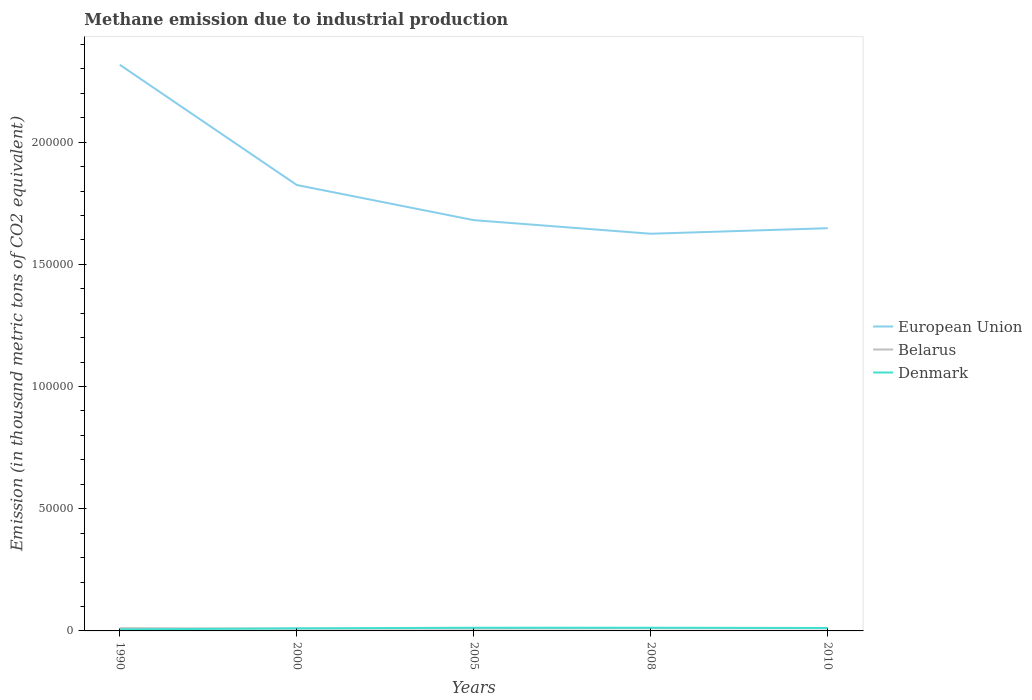Across all years, what is the maximum amount of methane emitted in Belarus?
Provide a succinct answer. 934.2. What is the total amount of methane emitted in Belarus in the graph?
Offer a terse response. -121.9. What is the difference between the highest and the second highest amount of methane emitted in European Union?
Offer a terse response. 6.91e+04. Is the amount of methane emitted in European Union strictly greater than the amount of methane emitted in Denmark over the years?
Provide a succinct answer. No. Does the graph contain any zero values?
Provide a short and direct response. No. Where does the legend appear in the graph?
Offer a very short reply. Center right. What is the title of the graph?
Offer a very short reply. Methane emission due to industrial production. What is the label or title of the X-axis?
Give a very brief answer. Years. What is the label or title of the Y-axis?
Provide a succinct answer. Emission (in thousand metric tons of CO2 equivalent). What is the Emission (in thousand metric tons of CO2 equivalent) of European Union in 1990?
Provide a short and direct response. 2.32e+05. What is the Emission (in thousand metric tons of CO2 equivalent) in Belarus in 1990?
Make the answer very short. 1133.2. What is the Emission (in thousand metric tons of CO2 equivalent) in Denmark in 1990?
Your response must be concise. 609.7. What is the Emission (in thousand metric tons of CO2 equivalent) of European Union in 2000?
Offer a terse response. 1.82e+05. What is the Emission (in thousand metric tons of CO2 equivalent) of Belarus in 2000?
Your response must be concise. 934.2. What is the Emission (in thousand metric tons of CO2 equivalent) in Denmark in 2000?
Offer a very short reply. 1056. What is the Emission (in thousand metric tons of CO2 equivalent) of European Union in 2005?
Provide a short and direct response. 1.68e+05. What is the Emission (in thousand metric tons of CO2 equivalent) in Belarus in 2005?
Ensure brevity in your answer.  955.3. What is the Emission (in thousand metric tons of CO2 equivalent) of Denmark in 2005?
Ensure brevity in your answer.  1303.1. What is the Emission (in thousand metric tons of CO2 equivalent) of European Union in 2008?
Provide a succinct answer. 1.63e+05. What is the Emission (in thousand metric tons of CO2 equivalent) in Belarus in 2008?
Offer a terse response. 1077.2. What is the Emission (in thousand metric tons of CO2 equivalent) of Denmark in 2008?
Keep it short and to the point. 1304.9. What is the Emission (in thousand metric tons of CO2 equivalent) of European Union in 2010?
Make the answer very short. 1.65e+05. What is the Emission (in thousand metric tons of CO2 equivalent) of Belarus in 2010?
Your response must be concise. 1046.7. What is the Emission (in thousand metric tons of CO2 equivalent) in Denmark in 2010?
Your response must be concise. 1206.8. Across all years, what is the maximum Emission (in thousand metric tons of CO2 equivalent) in European Union?
Your answer should be very brief. 2.32e+05. Across all years, what is the maximum Emission (in thousand metric tons of CO2 equivalent) of Belarus?
Your answer should be very brief. 1133.2. Across all years, what is the maximum Emission (in thousand metric tons of CO2 equivalent) in Denmark?
Provide a short and direct response. 1304.9. Across all years, what is the minimum Emission (in thousand metric tons of CO2 equivalent) of European Union?
Your answer should be compact. 1.63e+05. Across all years, what is the minimum Emission (in thousand metric tons of CO2 equivalent) of Belarus?
Ensure brevity in your answer.  934.2. Across all years, what is the minimum Emission (in thousand metric tons of CO2 equivalent) in Denmark?
Offer a very short reply. 609.7. What is the total Emission (in thousand metric tons of CO2 equivalent) of European Union in the graph?
Ensure brevity in your answer.  9.09e+05. What is the total Emission (in thousand metric tons of CO2 equivalent) of Belarus in the graph?
Ensure brevity in your answer.  5146.6. What is the total Emission (in thousand metric tons of CO2 equivalent) of Denmark in the graph?
Ensure brevity in your answer.  5480.5. What is the difference between the Emission (in thousand metric tons of CO2 equivalent) of European Union in 1990 and that in 2000?
Keep it short and to the point. 4.92e+04. What is the difference between the Emission (in thousand metric tons of CO2 equivalent) of Belarus in 1990 and that in 2000?
Offer a terse response. 199. What is the difference between the Emission (in thousand metric tons of CO2 equivalent) in Denmark in 1990 and that in 2000?
Your response must be concise. -446.3. What is the difference between the Emission (in thousand metric tons of CO2 equivalent) of European Union in 1990 and that in 2005?
Your answer should be very brief. 6.36e+04. What is the difference between the Emission (in thousand metric tons of CO2 equivalent) in Belarus in 1990 and that in 2005?
Your answer should be very brief. 177.9. What is the difference between the Emission (in thousand metric tons of CO2 equivalent) in Denmark in 1990 and that in 2005?
Provide a succinct answer. -693.4. What is the difference between the Emission (in thousand metric tons of CO2 equivalent) in European Union in 1990 and that in 2008?
Make the answer very short. 6.91e+04. What is the difference between the Emission (in thousand metric tons of CO2 equivalent) in Denmark in 1990 and that in 2008?
Offer a terse response. -695.2. What is the difference between the Emission (in thousand metric tons of CO2 equivalent) of European Union in 1990 and that in 2010?
Your response must be concise. 6.69e+04. What is the difference between the Emission (in thousand metric tons of CO2 equivalent) of Belarus in 1990 and that in 2010?
Offer a terse response. 86.5. What is the difference between the Emission (in thousand metric tons of CO2 equivalent) of Denmark in 1990 and that in 2010?
Your answer should be compact. -597.1. What is the difference between the Emission (in thousand metric tons of CO2 equivalent) of European Union in 2000 and that in 2005?
Make the answer very short. 1.44e+04. What is the difference between the Emission (in thousand metric tons of CO2 equivalent) of Belarus in 2000 and that in 2005?
Offer a very short reply. -21.1. What is the difference between the Emission (in thousand metric tons of CO2 equivalent) in Denmark in 2000 and that in 2005?
Offer a terse response. -247.1. What is the difference between the Emission (in thousand metric tons of CO2 equivalent) of European Union in 2000 and that in 2008?
Offer a terse response. 1.99e+04. What is the difference between the Emission (in thousand metric tons of CO2 equivalent) in Belarus in 2000 and that in 2008?
Your answer should be very brief. -143. What is the difference between the Emission (in thousand metric tons of CO2 equivalent) of Denmark in 2000 and that in 2008?
Offer a terse response. -248.9. What is the difference between the Emission (in thousand metric tons of CO2 equivalent) in European Union in 2000 and that in 2010?
Your answer should be compact. 1.77e+04. What is the difference between the Emission (in thousand metric tons of CO2 equivalent) of Belarus in 2000 and that in 2010?
Offer a very short reply. -112.5. What is the difference between the Emission (in thousand metric tons of CO2 equivalent) in Denmark in 2000 and that in 2010?
Make the answer very short. -150.8. What is the difference between the Emission (in thousand metric tons of CO2 equivalent) of European Union in 2005 and that in 2008?
Make the answer very short. 5562. What is the difference between the Emission (in thousand metric tons of CO2 equivalent) of Belarus in 2005 and that in 2008?
Keep it short and to the point. -121.9. What is the difference between the Emission (in thousand metric tons of CO2 equivalent) of Denmark in 2005 and that in 2008?
Offer a very short reply. -1.8. What is the difference between the Emission (in thousand metric tons of CO2 equivalent) in European Union in 2005 and that in 2010?
Provide a short and direct response. 3298.2. What is the difference between the Emission (in thousand metric tons of CO2 equivalent) in Belarus in 2005 and that in 2010?
Offer a terse response. -91.4. What is the difference between the Emission (in thousand metric tons of CO2 equivalent) in Denmark in 2005 and that in 2010?
Provide a succinct answer. 96.3. What is the difference between the Emission (in thousand metric tons of CO2 equivalent) of European Union in 2008 and that in 2010?
Keep it short and to the point. -2263.8. What is the difference between the Emission (in thousand metric tons of CO2 equivalent) in Belarus in 2008 and that in 2010?
Offer a terse response. 30.5. What is the difference between the Emission (in thousand metric tons of CO2 equivalent) in Denmark in 2008 and that in 2010?
Offer a very short reply. 98.1. What is the difference between the Emission (in thousand metric tons of CO2 equivalent) of European Union in 1990 and the Emission (in thousand metric tons of CO2 equivalent) of Belarus in 2000?
Offer a very short reply. 2.31e+05. What is the difference between the Emission (in thousand metric tons of CO2 equivalent) of European Union in 1990 and the Emission (in thousand metric tons of CO2 equivalent) of Denmark in 2000?
Give a very brief answer. 2.31e+05. What is the difference between the Emission (in thousand metric tons of CO2 equivalent) in Belarus in 1990 and the Emission (in thousand metric tons of CO2 equivalent) in Denmark in 2000?
Offer a terse response. 77.2. What is the difference between the Emission (in thousand metric tons of CO2 equivalent) in European Union in 1990 and the Emission (in thousand metric tons of CO2 equivalent) in Belarus in 2005?
Keep it short and to the point. 2.31e+05. What is the difference between the Emission (in thousand metric tons of CO2 equivalent) of European Union in 1990 and the Emission (in thousand metric tons of CO2 equivalent) of Denmark in 2005?
Your response must be concise. 2.30e+05. What is the difference between the Emission (in thousand metric tons of CO2 equivalent) of Belarus in 1990 and the Emission (in thousand metric tons of CO2 equivalent) of Denmark in 2005?
Your answer should be compact. -169.9. What is the difference between the Emission (in thousand metric tons of CO2 equivalent) in European Union in 1990 and the Emission (in thousand metric tons of CO2 equivalent) in Belarus in 2008?
Offer a terse response. 2.31e+05. What is the difference between the Emission (in thousand metric tons of CO2 equivalent) in European Union in 1990 and the Emission (in thousand metric tons of CO2 equivalent) in Denmark in 2008?
Offer a terse response. 2.30e+05. What is the difference between the Emission (in thousand metric tons of CO2 equivalent) of Belarus in 1990 and the Emission (in thousand metric tons of CO2 equivalent) of Denmark in 2008?
Make the answer very short. -171.7. What is the difference between the Emission (in thousand metric tons of CO2 equivalent) in European Union in 1990 and the Emission (in thousand metric tons of CO2 equivalent) in Belarus in 2010?
Keep it short and to the point. 2.31e+05. What is the difference between the Emission (in thousand metric tons of CO2 equivalent) in European Union in 1990 and the Emission (in thousand metric tons of CO2 equivalent) in Denmark in 2010?
Your answer should be compact. 2.30e+05. What is the difference between the Emission (in thousand metric tons of CO2 equivalent) in Belarus in 1990 and the Emission (in thousand metric tons of CO2 equivalent) in Denmark in 2010?
Ensure brevity in your answer.  -73.6. What is the difference between the Emission (in thousand metric tons of CO2 equivalent) in European Union in 2000 and the Emission (in thousand metric tons of CO2 equivalent) in Belarus in 2005?
Make the answer very short. 1.81e+05. What is the difference between the Emission (in thousand metric tons of CO2 equivalent) of European Union in 2000 and the Emission (in thousand metric tons of CO2 equivalent) of Denmark in 2005?
Provide a succinct answer. 1.81e+05. What is the difference between the Emission (in thousand metric tons of CO2 equivalent) of Belarus in 2000 and the Emission (in thousand metric tons of CO2 equivalent) of Denmark in 2005?
Ensure brevity in your answer.  -368.9. What is the difference between the Emission (in thousand metric tons of CO2 equivalent) in European Union in 2000 and the Emission (in thousand metric tons of CO2 equivalent) in Belarus in 2008?
Your response must be concise. 1.81e+05. What is the difference between the Emission (in thousand metric tons of CO2 equivalent) in European Union in 2000 and the Emission (in thousand metric tons of CO2 equivalent) in Denmark in 2008?
Provide a short and direct response. 1.81e+05. What is the difference between the Emission (in thousand metric tons of CO2 equivalent) in Belarus in 2000 and the Emission (in thousand metric tons of CO2 equivalent) in Denmark in 2008?
Make the answer very short. -370.7. What is the difference between the Emission (in thousand metric tons of CO2 equivalent) of European Union in 2000 and the Emission (in thousand metric tons of CO2 equivalent) of Belarus in 2010?
Give a very brief answer. 1.81e+05. What is the difference between the Emission (in thousand metric tons of CO2 equivalent) of European Union in 2000 and the Emission (in thousand metric tons of CO2 equivalent) of Denmark in 2010?
Make the answer very short. 1.81e+05. What is the difference between the Emission (in thousand metric tons of CO2 equivalent) in Belarus in 2000 and the Emission (in thousand metric tons of CO2 equivalent) in Denmark in 2010?
Keep it short and to the point. -272.6. What is the difference between the Emission (in thousand metric tons of CO2 equivalent) in European Union in 2005 and the Emission (in thousand metric tons of CO2 equivalent) in Belarus in 2008?
Keep it short and to the point. 1.67e+05. What is the difference between the Emission (in thousand metric tons of CO2 equivalent) of European Union in 2005 and the Emission (in thousand metric tons of CO2 equivalent) of Denmark in 2008?
Make the answer very short. 1.67e+05. What is the difference between the Emission (in thousand metric tons of CO2 equivalent) in Belarus in 2005 and the Emission (in thousand metric tons of CO2 equivalent) in Denmark in 2008?
Ensure brevity in your answer.  -349.6. What is the difference between the Emission (in thousand metric tons of CO2 equivalent) in European Union in 2005 and the Emission (in thousand metric tons of CO2 equivalent) in Belarus in 2010?
Provide a short and direct response. 1.67e+05. What is the difference between the Emission (in thousand metric tons of CO2 equivalent) of European Union in 2005 and the Emission (in thousand metric tons of CO2 equivalent) of Denmark in 2010?
Provide a succinct answer. 1.67e+05. What is the difference between the Emission (in thousand metric tons of CO2 equivalent) of Belarus in 2005 and the Emission (in thousand metric tons of CO2 equivalent) of Denmark in 2010?
Your response must be concise. -251.5. What is the difference between the Emission (in thousand metric tons of CO2 equivalent) of European Union in 2008 and the Emission (in thousand metric tons of CO2 equivalent) of Belarus in 2010?
Offer a very short reply. 1.61e+05. What is the difference between the Emission (in thousand metric tons of CO2 equivalent) in European Union in 2008 and the Emission (in thousand metric tons of CO2 equivalent) in Denmark in 2010?
Your answer should be compact. 1.61e+05. What is the difference between the Emission (in thousand metric tons of CO2 equivalent) of Belarus in 2008 and the Emission (in thousand metric tons of CO2 equivalent) of Denmark in 2010?
Give a very brief answer. -129.6. What is the average Emission (in thousand metric tons of CO2 equivalent) of European Union per year?
Your answer should be compact. 1.82e+05. What is the average Emission (in thousand metric tons of CO2 equivalent) of Belarus per year?
Offer a very short reply. 1029.32. What is the average Emission (in thousand metric tons of CO2 equivalent) in Denmark per year?
Keep it short and to the point. 1096.1. In the year 1990, what is the difference between the Emission (in thousand metric tons of CO2 equivalent) in European Union and Emission (in thousand metric tons of CO2 equivalent) in Belarus?
Keep it short and to the point. 2.31e+05. In the year 1990, what is the difference between the Emission (in thousand metric tons of CO2 equivalent) of European Union and Emission (in thousand metric tons of CO2 equivalent) of Denmark?
Your answer should be compact. 2.31e+05. In the year 1990, what is the difference between the Emission (in thousand metric tons of CO2 equivalent) of Belarus and Emission (in thousand metric tons of CO2 equivalent) of Denmark?
Provide a short and direct response. 523.5. In the year 2000, what is the difference between the Emission (in thousand metric tons of CO2 equivalent) in European Union and Emission (in thousand metric tons of CO2 equivalent) in Belarus?
Your answer should be very brief. 1.82e+05. In the year 2000, what is the difference between the Emission (in thousand metric tons of CO2 equivalent) of European Union and Emission (in thousand metric tons of CO2 equivalent) of Denmark?
Your answer should be compact. 1.81e+05. In the year 2000, what is the difference between the Emission (in thousand metric tons of CO2 equivalent) in Belarus and Emission (in thousand metric tons of CO2 equivalent) in Denmark?
Your answer should be very brief. -121.8. In the year 2005, what is the difference between the Emission (in thousand metric tons of CO2 equivalent) in European Union and Emission (in thousand metric tons of CO2 equivalent) in Belarus?
Provide a short and direct response. 1.67e+05. In the year 2005, what is the difference between the Emission (in thousand metric tons of CO2 equivalent) in European Union and Emission (in thousand metric tons of CO2 equivalent) in Denmark?
Offer a very short reply. 1.67e+05. In the year 2005, what is the difference between the Emission (in thousand metric tons of CO2 equivalent) in Belarus and Emission (in thousand metric tons of CO2 equivalent) in Denmark?
Ensure brevity in your answer.  -347.8. In the year 2008, what is the difference between the Emission (in thousand metric tons of CO2 equivalent) in European Union and Emission (in thousand metric tons of CO2 equivalent) in Belarus?
Your answer should be compact. 1.61e+05. In the year 2008, what is the difference between the Emission (in thousand metric tons of CO2 equivalent) of European Union and Emission (in thousand metric tons of CO2 equivalent) of Denmark?
Your response must be concise. 1.61e+05. In the year 2008, what is the difference between the Emission (in thousand metric tons of CO2 equivalent) of Belarus and Emission (in thousand metric tons of CO2 equivalent) of Denmark?
Keep it short and to the point. -227.7. In the year 2010, what is the difference between the Emission (in thousand metric tons of CO2 equivalent) in European Union and Emission (in thousand metric tons of CO2 equivalent) in Belarus?
Keep it short and to the point. 1.64e+05. In the year 2010, what is the difference between the Emission (in thousand metric tons of CO2 equivalent) in European Union and Emission (in thousand metric tons of CO2 equivalent) in Denmark?
Keep it short and to the point. 1.64e+05. In the year 2010, what is the difference between the Emission (in thousand metric tons of CO2 equivalent) of Belarus and Emission (in thousand metric tons of CO2 equivalent) of Denmark?
Provide a succinct answer. -160.1. What is the ratio of the Emission (in thousand metric tons of CO2 equivalent) of European Union in 1990 to that in 2000?
Provide a succinct answer. 1.27. What is the ratio of the Emission (in thousand metric tons of CO2 equivalent) in Belarus in 1990 to that in 2000?
Make the answer very short. 1.21. What is the ratio of the Emission (in thousand metric tons of CO2 equivalent) in Denmark in 1990 to that in 2000?
Provide a succinct answer. 0.58. What is the ratio of the Emission (in thousand metric tons of CO2 equivalent) of European Union in 1990 to that in 2005?
Offer a very short reply. 1.38. What is the ratio of the Emission (in thousand metric tons of CO2 equivalent) of Belarus in 1990 to that in 2005?
Offer a terse response. 1.19. What is the ratio of the Emission (in thousand metric tons of CO2 equivalent) in Denmark in 1990 to that in 2005?
Provide a short and direct response. 0.47. What is the ratio of the Emission (in thousand metric tons of CO2 equivalent) in European Union in 1990 to that in 2008?
Make the answer very short. 1.43. What is the ratio of the Emission (in thousand metric tons of CO2 equivalent) in Belarus in 1990 to that in 2008?
Give a very brief answer. 1.05. What is the ratio of the Emission (in thousand metric tons of CO2 equivalent) of Denmark in 1990 to that in 2008?
Provide a short and direct response. 0.47. What is the ratio of the Emission (in thousand metric tons of CO2 equivalent) in European Union in 1990 to that in 2010?
Your answer should be very brief. 1.41. What is the ratio of the Emission (in thousand metric tons of CO2 equivalent) of Belarus in 1990 to that in 2010?
Your response must be concise. 1.08. What is the ratio of the Emission (in thousand metric tons of CO2 equivalent) of Denmark in 1990 to that in 2010?
Your answer should be very brief. 0.51. What is the ratio of the Emission (in thousand metric tons of CO2 equivalent) of European Union in 2000 to that in 2005?
Give a very brief answer. 1.09. What is the ratio of the Emission (in thousand metric tons of CO2 equivalent) in Belarus in 2000 to that in 2005?
Keep it short and to the point. 0.98. What is the ratio of the Emission (in thousand metric tons of CO2 equivalent) in Denmark in 2000 to that in 2005?
Ensure brevity in your answer.  0.81. What is the ratio of the Emission (in thousand metric tons of CO2 equivalent) of European Union in 2000 to that in 2008?
Your response must be concise. 1.12. What is the ratio of the Emission (in thousand metric tons of CO2 equivalent) of Belarus in 2000 to that in 2008?
Your response must be concise. 0.87. What is the ratio of the Emission (in thousand metric tons of CO2 equivalent) of Denmark in 2000 to that in 2008?
Ensure brevity in your answer.  0.81. What is the ratio of the Emission (in thousand metric tons of CO2 equivalent) in European Union in 2000 to that in 2010?
Provide a succinct answer. 1.11. What is the ratio of the Emission (in thousand metric tons of CO2 equivalent) in Belarus in 2000 to that in 2010?
Keep it short and to the point. 0.89. What is the ratio of the Emission (in thousand metric tons of CO2 equivalent) in Denmark in 2000 to that in 2010?
Your answer should be compact. 0.88. What is the ratio of the Emission (in thousand metric tons of CO2 equivalent) in European Union in 2005 to that in 2008?
Your answer should be very brief. 1.03. What is the ratio of the Emission (in thousand metric tons of CO2 equivalent) of Belarus in 2005 to that in 2008?
Your answer should be compact. 0.89. What is the ratio of the Emission (in thousand metric tons of CO2 equivalent) of European Union in 2005 to that in 2010?
Give a very brief answer. 1.02. What is the ratio of the Emission (in thousand metric tons of CO2 equivalent) of Belarus in 2005 to that in 2010?
Make the answer very short. 0.91. What is the ratio of the Emission (in thousand metric tons of CO2 equivalent) of Denmark in 2005 to that in 2010?
Your answer should be very brief. 1.08. What is the ratio of the Emission (in thousand metric tons of CO2 equivalent) in European Union in 2008 to that in 2010?
Give a very brief answer. 0.99. What is the ratio of the Emission (in thousand metric tons of CO2 equivalent) in Belarus in 2008 to that in 2010?
Your answer should be compact. 1.03. What is the ratio of the Emission (in thousand metric tons of CO2 equivalent) of Denmark in 2008 to that in 2010?
Keep it short and to the point. 1.08. What is the difference between the highest and the second highest Emission (in thousand metric tons of CO2 equivalent) in European Union?
Your answer should be very brief. 4.92e+04. What is the difference between the highest and the second highest Emission (in thousand metric tons of CO2 equivalent) of Denmark?
Provide a succinct answer. 1.8. What is the difference between the highest and the lowest Emission (in thousand metric tons of CO2 equivalent) in European Union?
Your answer should be very brief. 6.91e+04. What is the difference between the highest and the lowest Emission (in thousand metric tons of CO2 equivalent) in Belarus?
Give a very brief answer. 199. What is the difference between the highest and the lowest Emission (in thousand metric tons of CO2 equivalent) of Denmark?
Give a very brief answer. 695.2. 